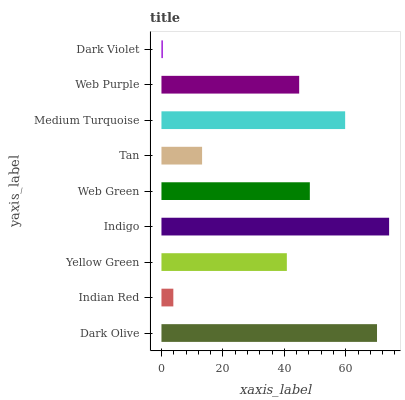Is Dark Violet the minimum?
Answer yes or no. Yes. Is Indigo the maximum?
Answer yes or no. Yes. Is Indian Red the minimum?
Answer yes or no. No. Is Indian Red the maximum?
Answer yes or no. No. Is Dark Olive greater than Indian Red?
Answer yes or no. Yes. Is Indian Red less than Dark Olive?
Answer yes or no. Yes. Is Indian Red greater than Dark Olive?
Answer yes or no. No. Is Dark Olive less than Indian Red?
Answer yes or no. No. Is Web Purple the high median?
Answer yes or no. Yes. Is Web Purple the low median?
Answer yes or no. Yes. Is Indigo the high median?
Answer yes or no. No. Is Indigo the low median?
Answer yes or no. No. 